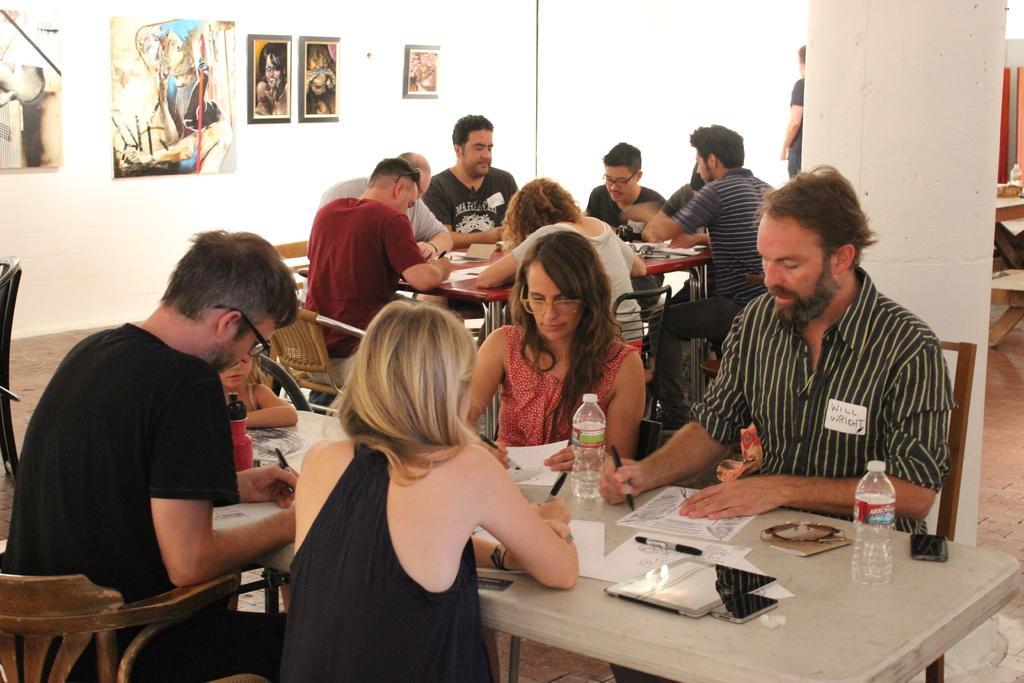Can you describe this image briefly? This picture describes about group of people few are seated on the chair and few are standing, in front of them we can find water bottles, papers, pens, mobiles on the table, in the background we can see wall paintings on the wall. 